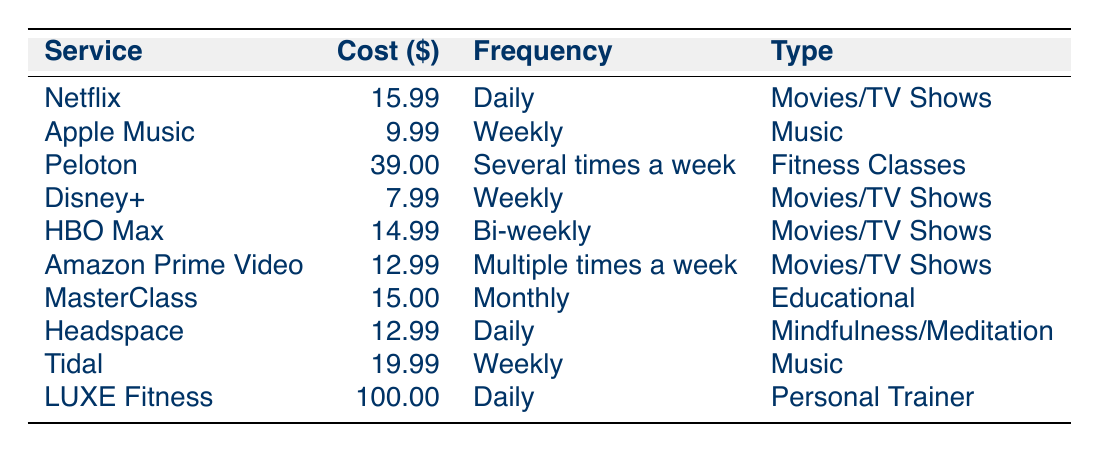What is the monthly cost of Netflix? The table lists Netflix with a monthly cost of $15.99.
Answer: 15.99 How often does the household using LUXE Fitness utilize the service? The table indicates that the household using LUXE Fitness utilizes the service daily.
Answer: Daily Which service has the highest monthly cost? The table shows that LUXE Fitness has the highest monthly cost at $100.00.
Answer: LUXE Fitness How many services are utilized daily by the households? The table lists two services utilized daily: Netflix and Headspace.
Answer: 2 What is the average monthly cost of all the listed services? The sum of the monthly costs is (15.99 + 9.99 + 39.00 + 7.99 + 14.99 + 12.99 + 15.00 + 12.99 + 19.99 + 100.00) = 315.92. There are 10 services, so the average is 315.92 / 10 = 31.59.
Answer: 31.59 Is Amazon Prime Video used more frequently than HBO Max? According to the table, Amazon Prime Video is used multiple times a week, while HBO Max is used bi-weekly, indicating it is used more frequently.
Answer: Yes Which type of content has the most services listed? The table shows that “Movies/TV Shows” has four services (Netflix, Disney+, HBO Max, Amazon Prime Video), which is the highest among categories.
Answer: Movies/TV Shows What is the difference in monthly cost between Peloton and Disney+? Peloton costs $39.00 and Disney+ costs $7.99. The difference is 39.00 - 7.99 = 31.01.
Answer: 31.01 Do any households utilize multiple services daily? The table shows two services used daily, but they belong to separate households, indicating that no household utilizes multiple services daily.
Answer: No How many music services have a weekly utilization frequency? The table lists two music services with a weekly utilization frequency: Apple Music and Tidal.
Answer: 2 